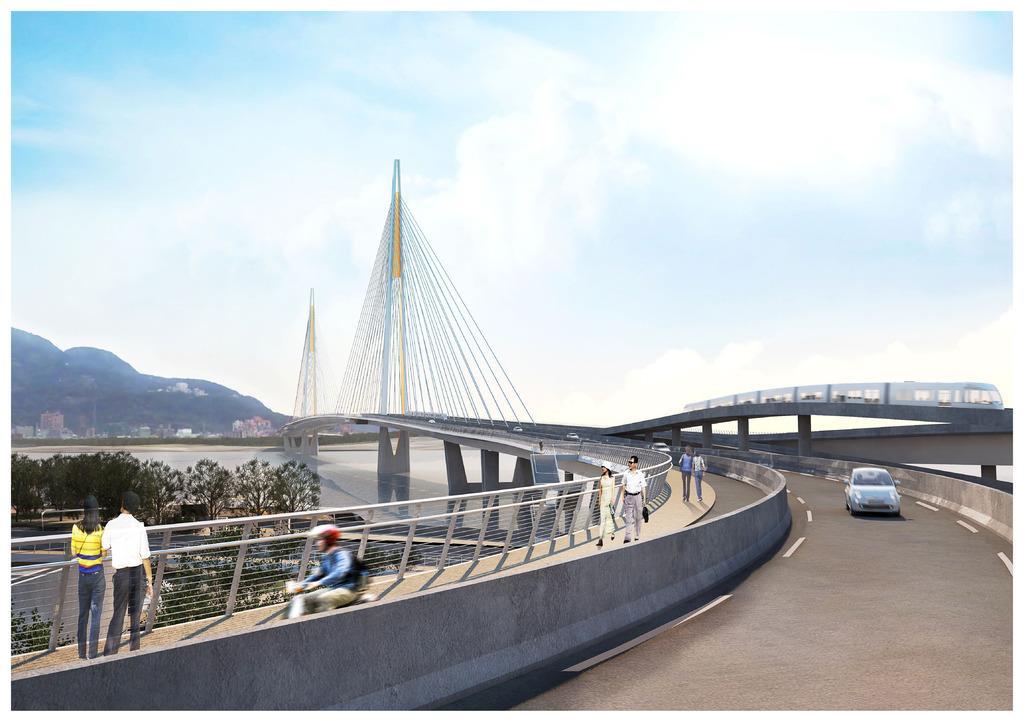How would you summarize this image in a sentence or two? The picture is looking like a depiction. In the foreground of the picture there is a bridge, on the bridge there are people, motorbike and a car. On the left there are trees, water body, buildings and hills. In the center of the picture there is a bridge. Towards right there is bridge and train. At the top it is sky. 